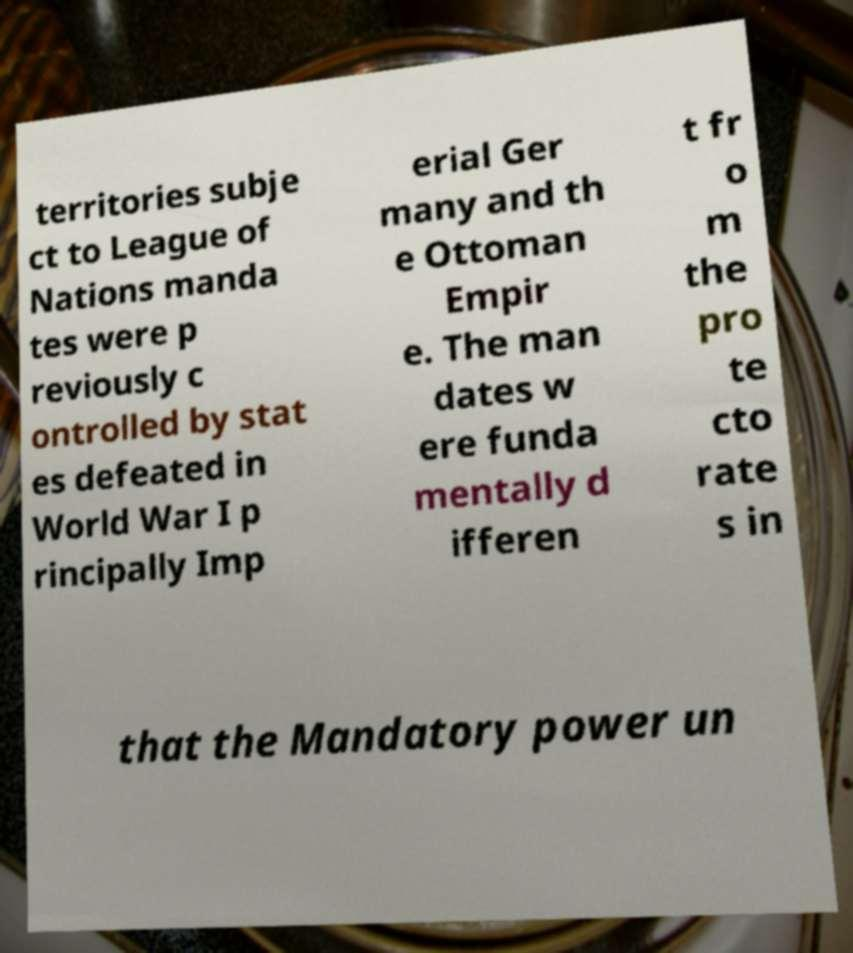There's text embedded in this image that I need extracted. Can you transcribe it verbatim? territories subje ct to League of Nations manda tes were p reviously c ontrolled by stat es defeated in World War I p rincipally Imp erial Ger many and th e Ottoman Empir e. The man dates w ere funda mentally d ifferen t fr o m the pro te cto rate s in that the Mandatory power un 